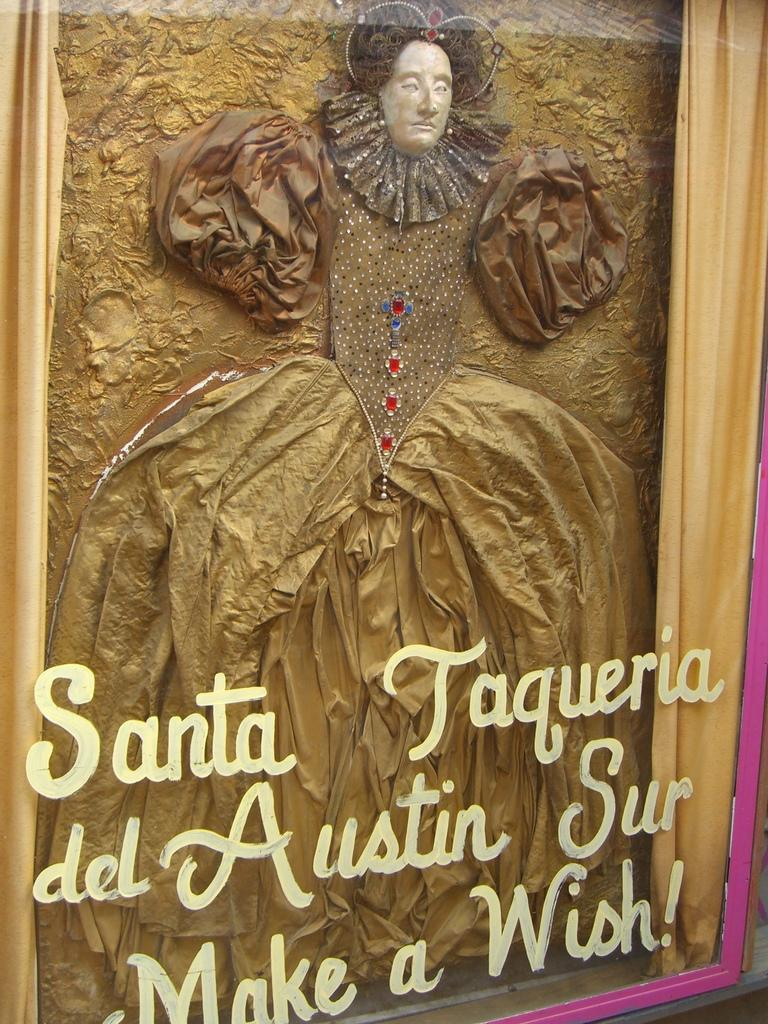What type of object is present in the image that is made of fabric? There is a cloth in the image. What type of artwork can be seen in the image? There is a sculpture in the image. What object in the image has text on it? There is a glass with text in the image. What type of bait is used to catch fish in the image? There is no bait or fishing activity present in the image. Is there a boat visible in the image? No, there is no boat present in the image. 